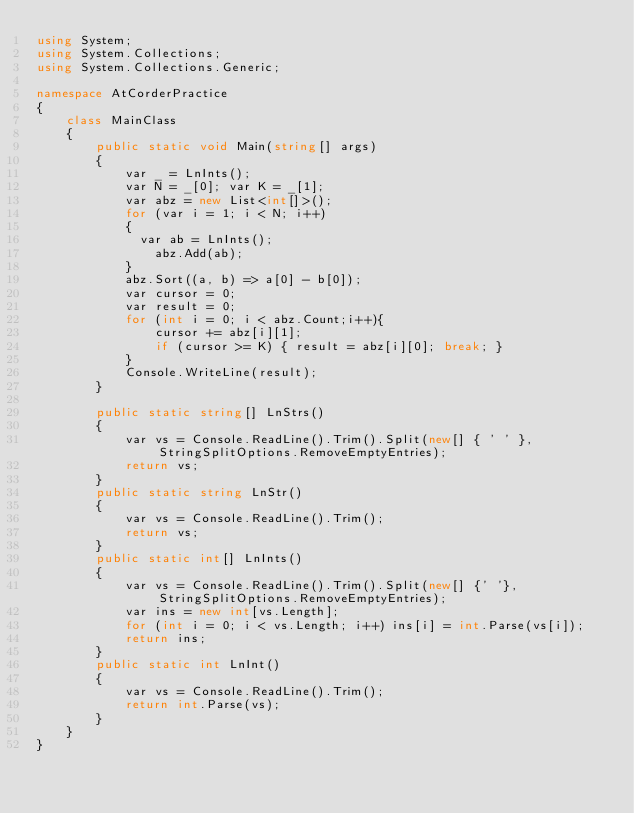Convert code to text. <code><loc_0><loc_0><loc_500><loc_500><_C#_>using System;
using System.Collections;
using System.Collections.Generic;

namespace AtCorderPractice
{
    class MainClass
    {
        public static void Main(string[] args)
        {
            var _ = LnInts();
            var N = _[0]; var K = _[1];
            var abz = new List<int[]>();
            for (var i = 1; i < N; i++)
            {
              var ab = LnInts();
                abz.Add(ab);
            }
            abz.Sort((a, b) => a[0] - b[0]);
            var cursor = 0;
            var result = 0;
            for (int i = 0; i < abz.Count;i++){
                cursor += abz[i][1];
                if (cursor >= K) { result = abz[i][0]; break; }
            }
            Console.WriteLine(result);
        }

        public static string[] LnStrs()
        {
            var vs = Console.ReadLine().Trim().Split(new[] { ' ' }, StringSplitOptions.RemoveEmptyEntries);
            return vs;
        }
        public static string LnStr()
        {
            var vs = Console.ReadLine().Trim();
            return vs;
        }
        public static int[] LnInts()
        {
            var vs = Console.ReadLine().Trim().Split(new[] {' '},StringSplitOptions.RemoveEmptyEntries);
            var ins = new int[vs.Length];
            for (int i = 0; i < vs.Length; i++) ins[i] = int.Parse(vs[i]);
            return ins;
        }
        public static int LnInt()
        {
            var vs = Console.ReadLine().Trim();
            return int.Parse(vs);
        }
    }
}
</code> 